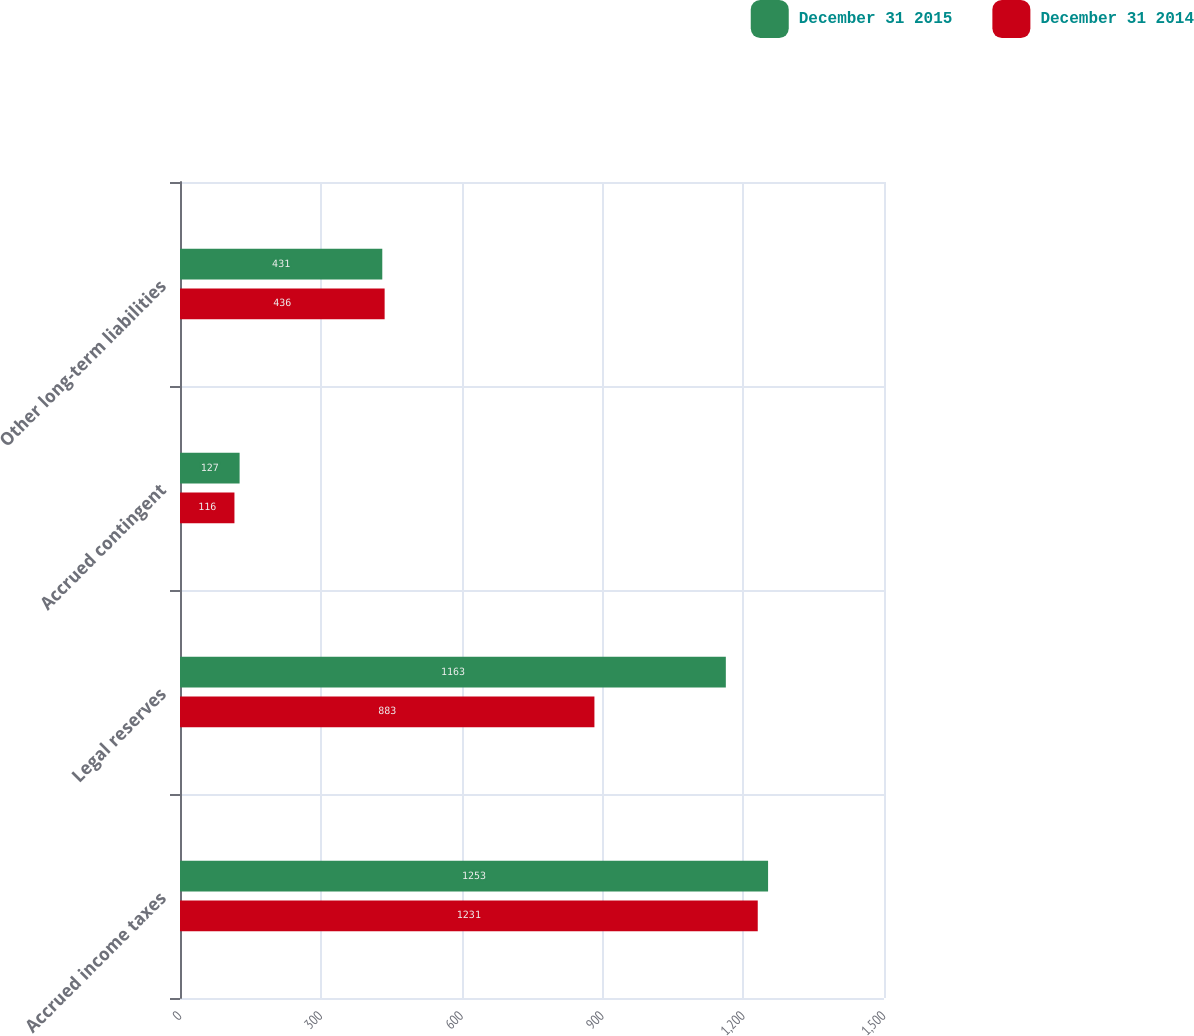Convert chart. <chart><loc_0><loc_0><loc_500><loc_500><stacked_bar_chart><ecel><fcel>Accrued income taxes<fcel>Legal reserves<fcel>Accrued contingent<fcel>Other long-term liabilities<nl><fcel>December 31 2015<fcel>1253<fcel>1163<fcel>127<fcel>431<nl><fcel>December 31 2014<fcel>1231<fcel>883<fcel>116<fcel>436<nl></chart> 